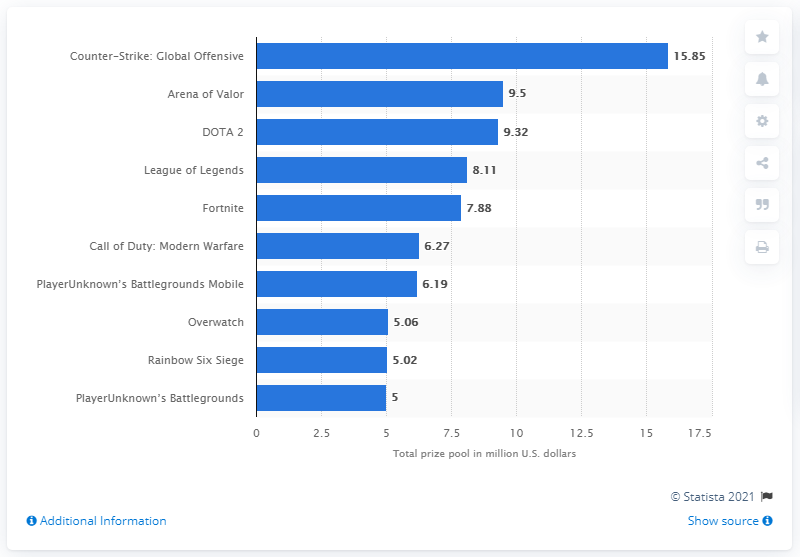Indicate a few pertinent items in this graphic. The prize pool in Counter-Strike: Global Offensive in 2020 was worth approximately $15.85 million in US dollars. In 2020, Counter-Strike: Global Offensive was the top-ranked game in the eSports scene, earning the top spot in the rankings. In 2020, League of Legends was ranked as the fourth most popular eSports game. 